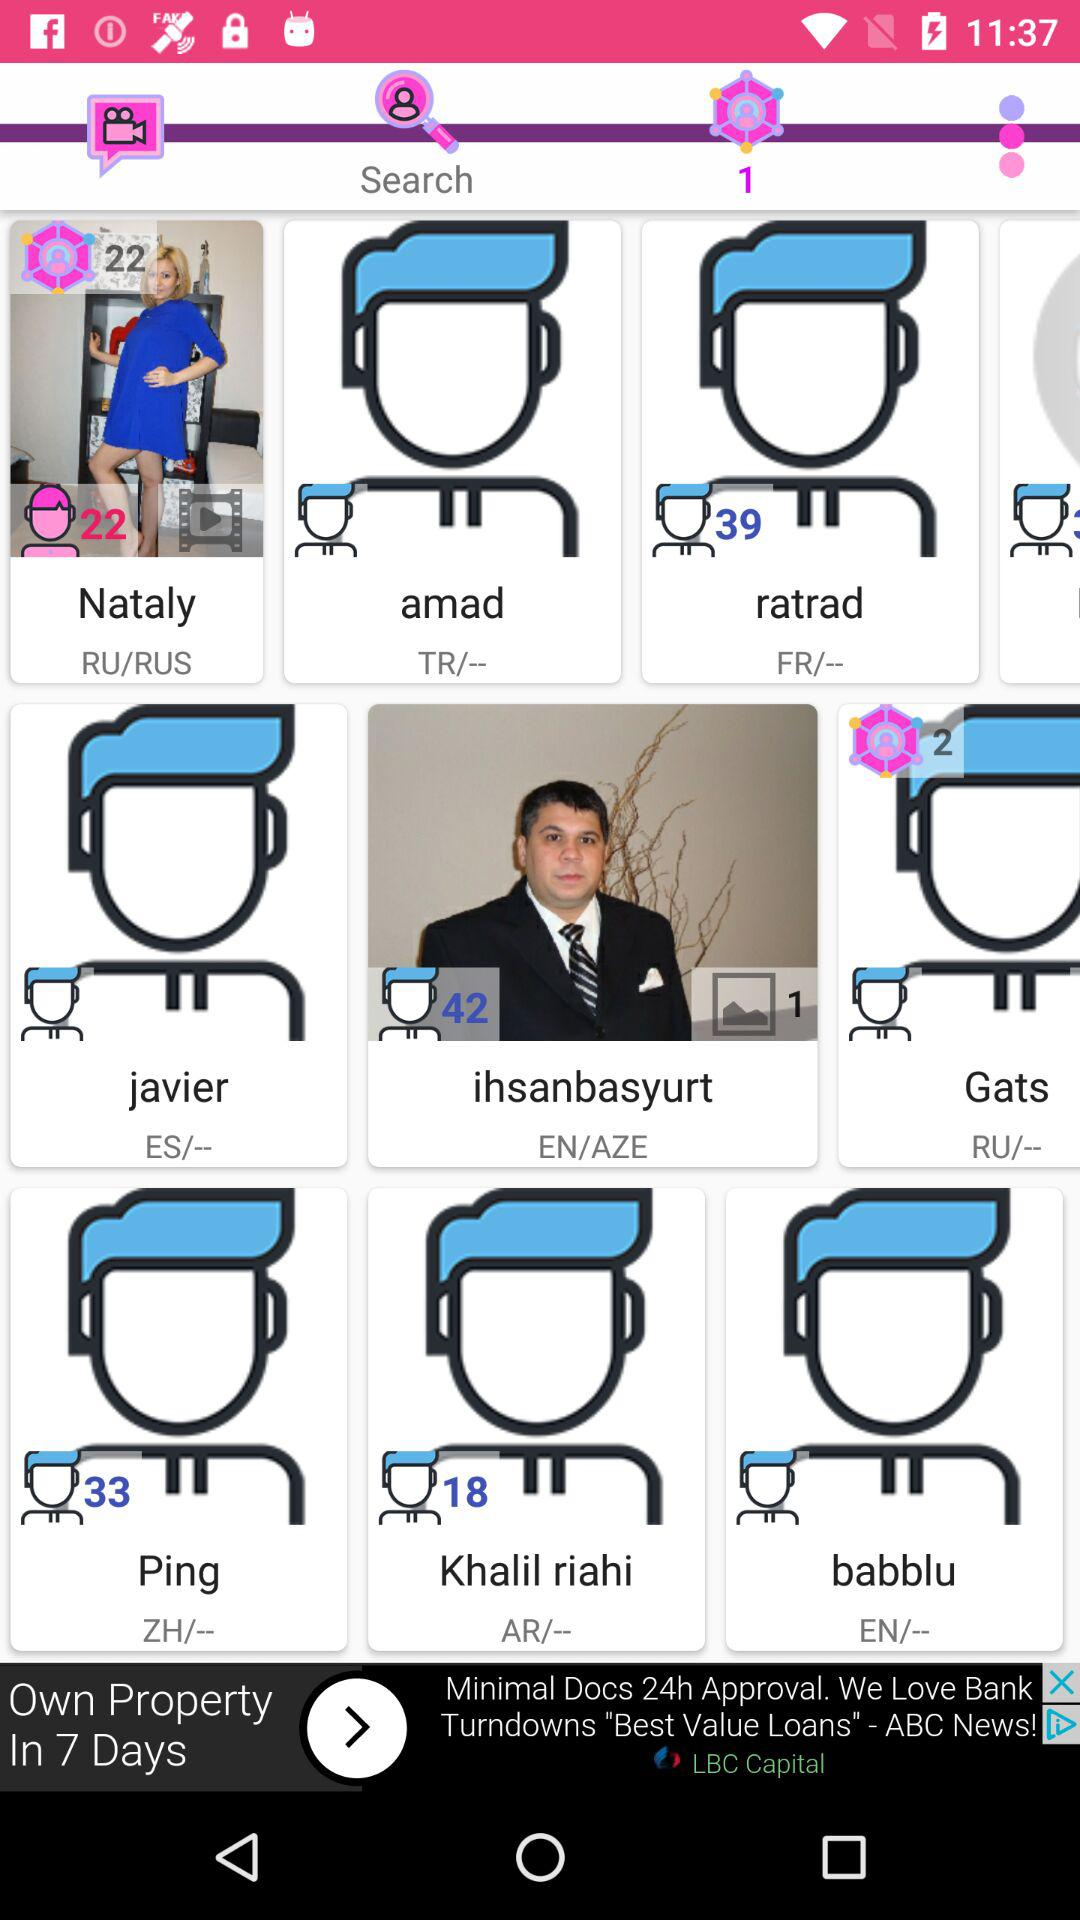What is the age of Ping? Ping is 33 years old. 